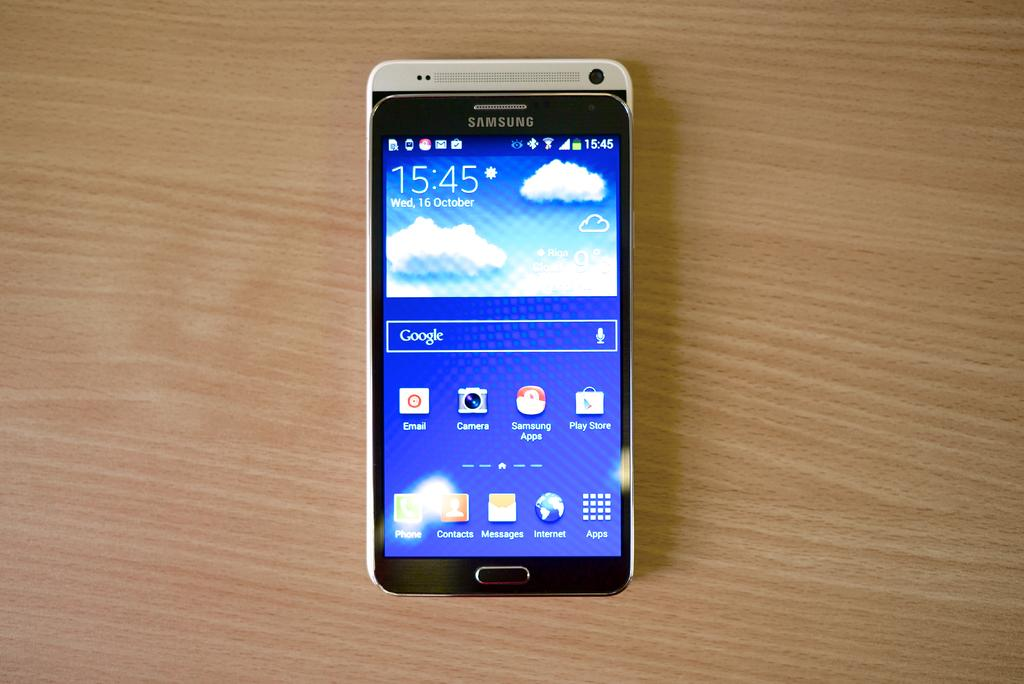<image>
Provide a brief description of the given image. A phone screen shows that the date is the 16th of October. 